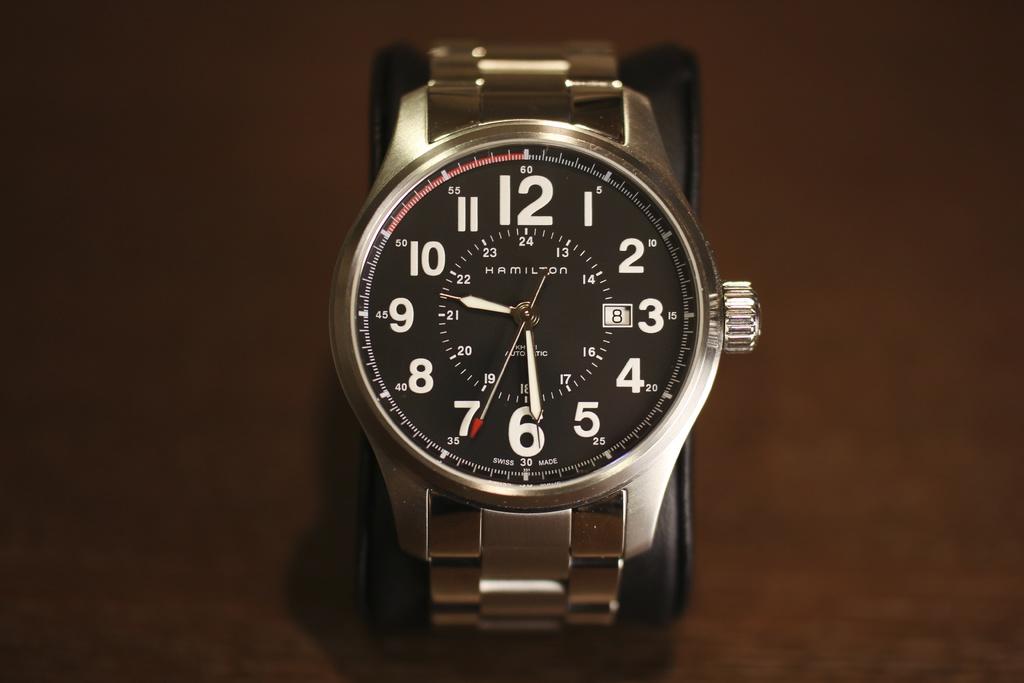According to this watch, what day of the month is it?
Ensure brevity in your answer.  8. 